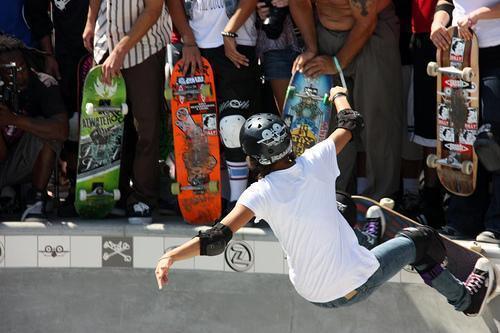Where did OG skateboarders develop this style of boarding?
Choose the correct response, then elucidate: 'Answer: answer
Rationale: rationale.'
Options: Underpasses, skateparks, canals, swimming pools. Answer: swimming pools.
Rationale: In california many people have these in their backyard and empty ones are deep enough to practice skating tricks. 